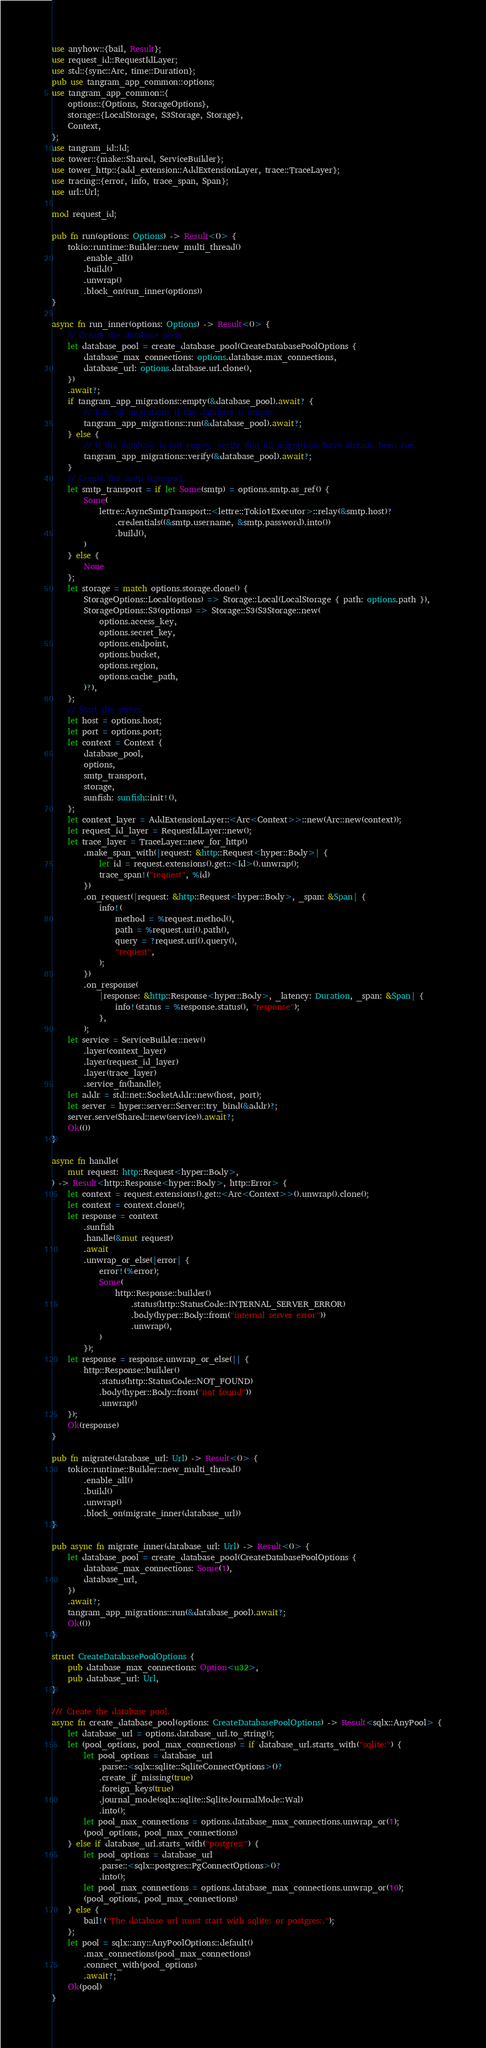<code> <loc_0><loc_0><loc_500><loc_500><_Rust_>use anyhow::{bail, Result};
use request_id::RequestIdLayer;
use std::{sync::Arc, time::Duration};
pub use tangram_app_common::options;
use tangram_app_common::{
	options::{Options, StorageOptions},
	storage::{LocalStorage, S3Storage, Storage},
	Context,
};
use tangram_id::Id;
use tower::{make::Shared, ServiceBuilder};
use tower_http::{add_extension::AddExtensionLayer, trace::TraceLayer};
use tracing::{error, info, trace_span, Span};
use url::Url;

mod request_id;

pub fn run(options: Options) -> Result<()> {
	tokio::runtime::Builder::new_multi_thread()
		.enable_all()
		.build()
		.unwrap()
		.block_on(run_inner(options))
}

async fn run_inner(options: Options) -> Result<()> {
	// Create the database pool.
	let database_pool = create_database_pool(CreateDatabasePoolOptions {
		database_max_connections: options.database.max_connections,
		database_url: options.database.url.clone(),
	})
	.await?;
	if tangram_app_migrations::empty(&database_pool).await? {
		// Run all migrations if the database is empty.
		tangram_app_migrations::run(&database_pool).await?;
	} else {
		// If the database is not empty, verify that all migrations have already been run.
		tangram_app_migrations::verify(&database_pool).await?;
	}
	// Create the smtp transport.
	let smtp_transport = if let Some(smtp) = options.smtp.as_ref() {
		Some(
			lettre::AsyncSmtpTransport::<lettre::Tokio1Executor>::relay(&smtp.host)?
				.credentials((&smtp.username, &smtp.password).into())
				.build(),
		)
	} else {
		None
	};
	let storage = match options.storage.clone() {
		StorageOptions::Local(options) => Storage::Local(LocalStorage { path: options.path }),
		StorageOptions::S3(options) => Storage::S3(S3Storage::new(
			options.access_key,
			options.secret_key,
			options.endpoint,
			options.bucket,
			options.region,
			options.cache_path,
		)?),
	};
	// Start the server.
	let host = options.host;
	let port = options.port;
	let context = Context {
		database_pool,
		options,
		smtp_transport,
		storage,
		sunfish: sunfish::init!(),
	};
	let context_layer = AddExtensionLayer::<Arc<Context>>::new(Arc::new(context));
	let request_id_layer = RequestIdLayer::new();
	let trace_layer = TraceLayer::new_for_http()
		.make_span_with(|request: &http::Request<hyper::Body>| {
			let id = request.extensions().get::<Id>().unwrap();
			trace_span!("request", %id)
		})
		.on_request(|request: &http::Request<hyper::Body>, _span: &Span| {
			info!(
				method = %request.method(),
				path = %request.uri().path(),
				query = ?request.uri().query(),
				"request",
			);
		})
		.on_response(
			|response: &http::Response<hyper::Body>, _latency: Duration, _span: &Span| {
				info!(status = %response.status(), "response");
			},
		);
	let service = ServiceBuilder::new()
		.layer(context_layer)
		.layer(request_id_layer)
		.layer(trace_layer)
		.service_fn(handle);
	let addr = std::net::SocketAddr::new(host, port);
	let server = hyper::server::Server::try_bind(&addr)?;
	server.serve(Shared::new(service)).await?;
	Ok(())
}

async fn handle(
	mut request: http::Request<hyper::Body>,
) -> Result<http::Response<hyper::Body>, http::Error> {
	let context = request.extensions().get::<Arc<Context>>().unwrap().clone();
	let context = context.clone();
	let response = context
		.sunfish
		.handle(&mut request)
		.await
		.unwrap_or_else(|error| {
			error!(%error);
			Some(
				http::Response::builder()
					.status(http::StatusCode::INTERNAL_SERVER_ERROR)
					.body(hyper::Body::from("internal server error"))
					.unwrap(),
			)
		});
	let response = response.unwrap_or_else(|| {
		http::Response::builder()
			.status(http::StatusCode::NOT_FOUND)
			.body(hyper::Body::from("not found"))
			.unwrap()
	});
	Ok(response)
}

pub fn migrate(database_url: Url) -> Result<()> {
	tokio::runtime::Builder::new_multi_thread()
		.enable_all()
		.build()
		.unwrap()
		.block_on(migrate_inner(database_url))
}

pub async fn migrate_inner(database_url: Url) -> Result<()> {
	let database_pool = create_database_pool(CreateDatabasePoolOptions {
		database_max_connections: Some(1),
		database_url,
	})
	.await?;
	tangram_app_migrations::run(&database_pool).await?;
	Ok(())
}

struct CreateDatabasePoolOptions {
	pub database_max_connections: Option<u32>,
	pub database_url: Url,
}

/// Create the database pool.
async fn create_database_pool(options: CreateDatabasePoolOptions) -> Result<sqlx::AnyPool> {
	let database_url = options.database_url.to_string();
	let (pool_options, pool_max_connections) = if database_url.starts_with("sqlite:") {
		let pool_options = database_url
			.parse::<sqlx::sqlite::SqliteConnectOptions>()?
			.create_if_missing(true)
			.foreign_keys(true)
			.journal_mode(sqlx::sqlite::SqliteJournalMode::Wal)
			.into();
		let pool_max_connections = options.database_max_connections.unwrap_or(1);
		(pool_options, pool_max_connections)
	} else if database_url.starts_with("postgres:") {
		let pool_options = database_url
			.parse::<sqlx::postgres::PgConnectOptions>()?
			.into();
		let pool_max_connections = options.database_max_connections.unwrap_or(10);
		(pool_options, pool_max_connections)
	} else {
		bail!("The database url must start with sqlite: or postgres:.");
	};
	let pool = sqlx::any::AnyPoolOptions::default()
		.max_connections(pool_max_connections)
		.connect_with(pool_options)
		.await?;
	Ok(pool)
}
</code> 